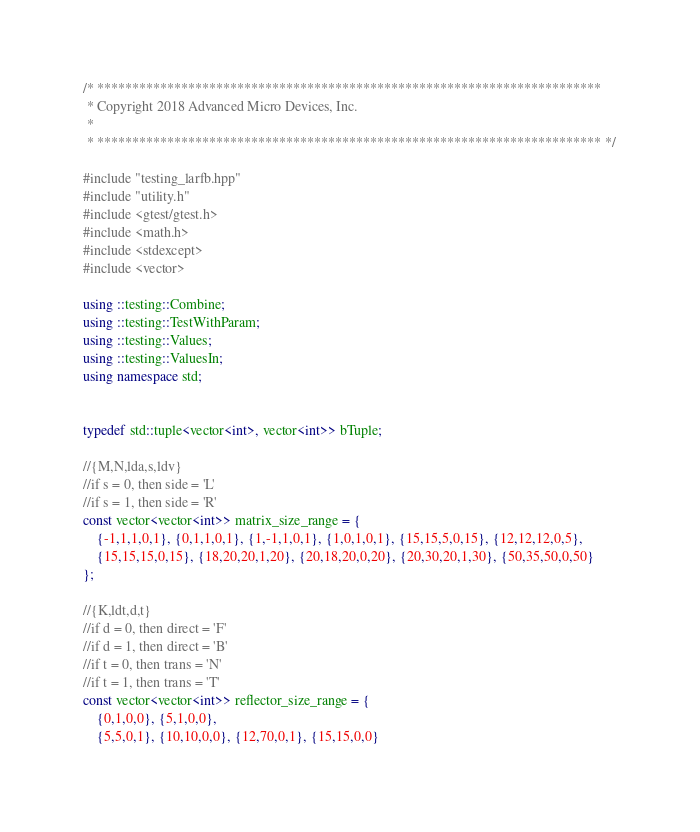<code> <loc_0><loc_0><loc_500><loc_500><_C++_>/* ************************************************************************
 * Copyright 2018 Advanced Micro Devices, Inc.
 *
 * ************************************************************************ */

#include "testing_larfb.hpp"
#include "utility.h"
#include <gtest/gtest.h>
#include <math.h>
#include <stdexcept>
#include <vector>

using ::testing::Combine;
using ::testing::TestWithParam;
using ::testing::Values;
using ::testing::ValuesIn;
using namespace std;


typedef std::tuple<vector<int>, vector<int>> bTuple;

//{M,N,lda,s,ldv}
//if s = 0, then side = 'L'
//if s = 1, then side = 'R'
const vector<vector<int>> matrix_size_range = {
    {-1,1,1,0,1}, {0,1,1,0,1}, {1,-1,1,0,1}, {1,0,1,0,1}, {15,15,5,0,15}, {12,12,12,0,5}, 
    {15,15,15,0,15}, {18,20,20,1,20}, {20,18,20,0,20}, {20,30,20,1,30}, {50,35,50,0,50}  
};

//{K,ldt,d,t}
//if d = 0, then direct = 'F'
//if d = 1, then direct = 'B'
//if t = 0, then trans = 'N'
//if t = 1, then trans = 'T'
const vector<vector<int>> reflector_size_range = {
    {0,1,0,0}, {5,1,0,0}, 
    {5,5,0,1}, {10,10,0,0}, {12,70,0,1}, {15,15,0,0}</code> 